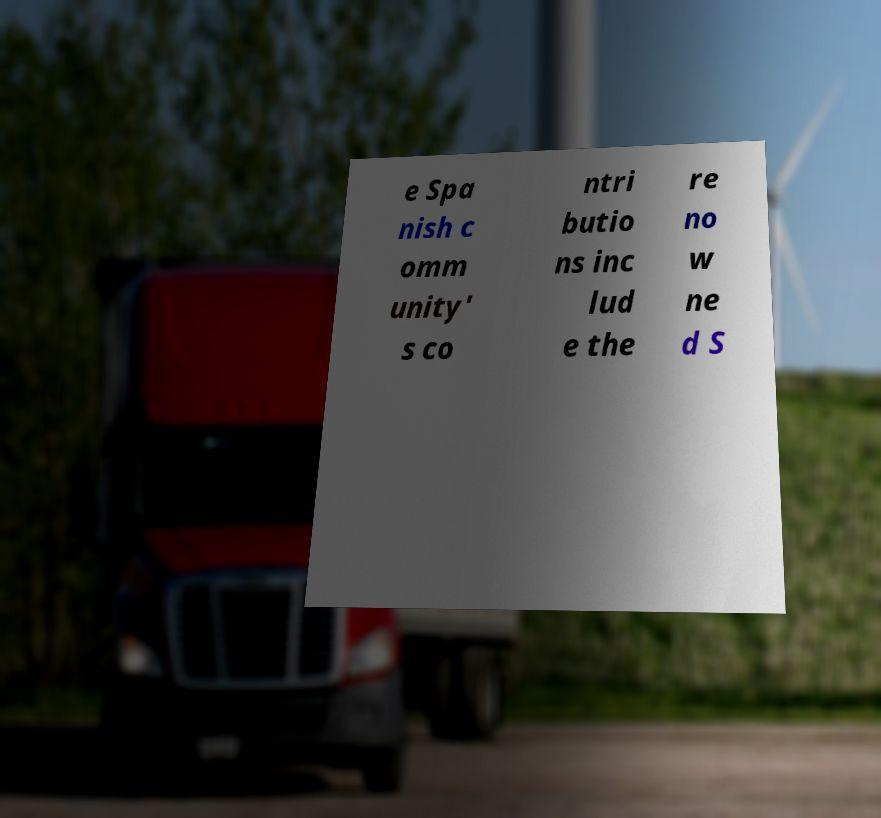Can you read and provide the text displayed in the image?This photo seems to have some interesting text. Can you extract and type it out for me? e Spa nish c omm unity' s co ntri butio ns inc lud e the re no w ne d S 